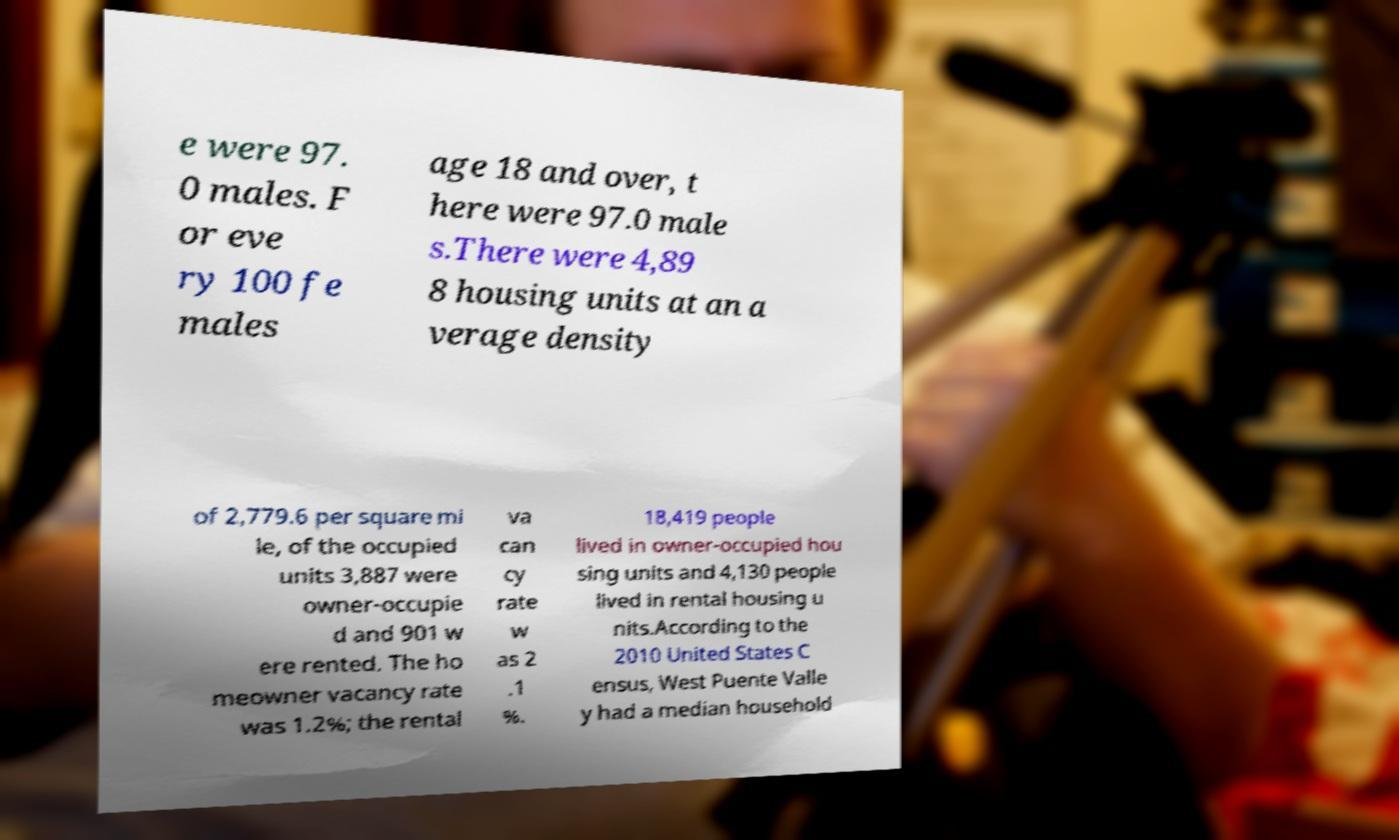Can you read and provide the text displayed in the image?This photo seems to have some interesting text. Can you extract and type it out for me? e were 97. 0 males. F or eve ry 100 fe males age 18 and over, t here were 97.0 male s.There were 4,89 8 housing units at an a verage density of 2,779.6 per square mi le, of the occupied units 3,887 were owner-occupie d and 901 w ere rented. The ho meowner vacancy rate was 1.2%; the rental va can cy rate w as 2 .1 %. 18,419 people lived in owner-occupied hou sing units and 4,130 people lived in rental housing u nits.According to the 2010 United States C ensus, West Puente Valle y had a median household 